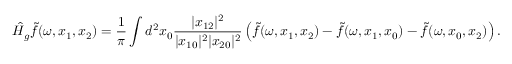<formula> <loc_0><loc_0><loc_500><loc_500>\hat { H } _ { g } \widetilde { f } ( \omega , x _ { 1 } , x _ { 2 } ) = \frac { 1 } { \pi } \int d ^ { 2 } x _ { 0 } \frac { | x _ { 1 2 } | ^ { 2 } } { | x _ { 1 0 } | ^ { 2 } | x _ { 2 0 } | ^ { 2 } } \left ( \widetilde { f } ( \omega , x _ { 1 } , x _ { 2 } ) - \widetilde { f } ( \omega , x _ { 1 } , x _ { 0 } ) - \widetilde { f } ( \omega , x _ { 0 } , x _ { 2 } ) \right ) .</formula> 